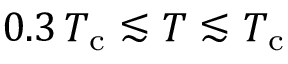<formula> <loc_0><loc_0><loc_500><loc_500>0 . 3 \, T _ { c } \lesssim T \lesssim T _ { c }</formula> 